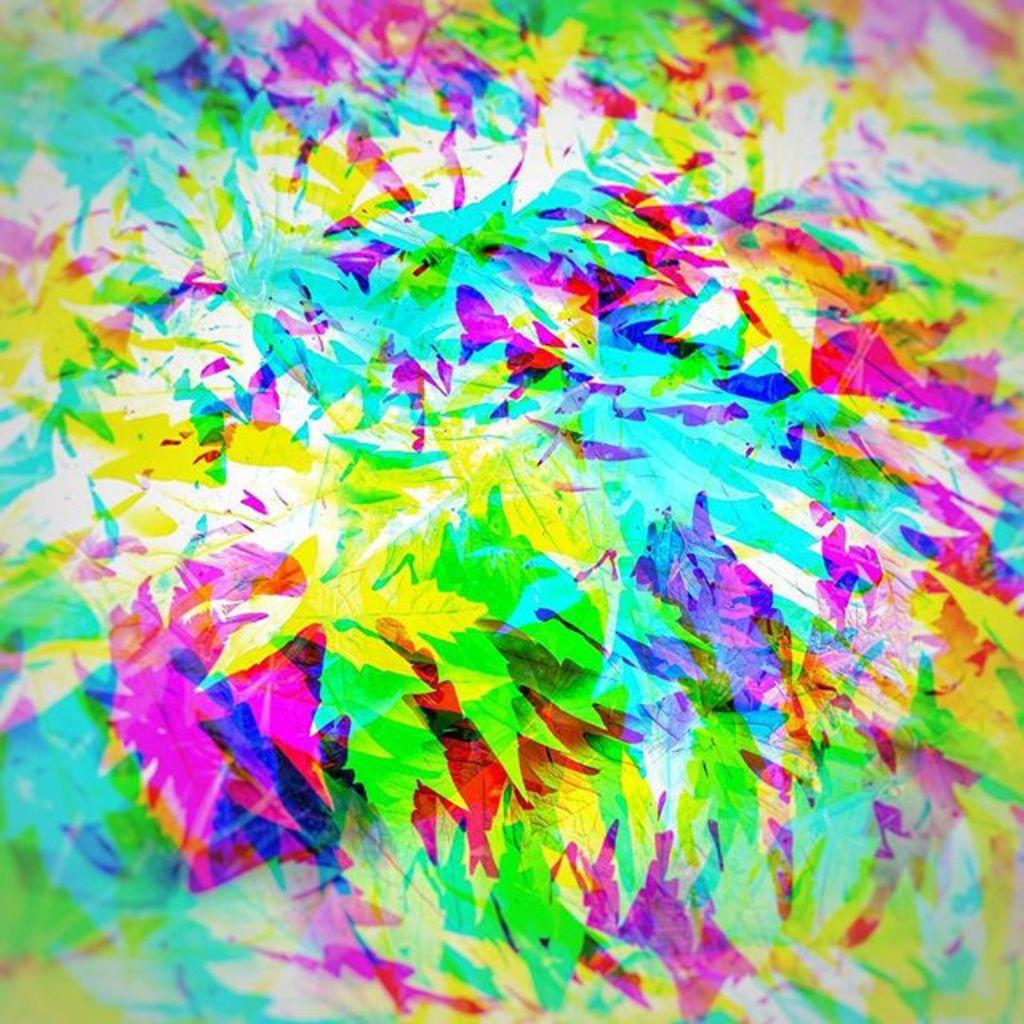What is the main subject of the image? The main subject of the image is an art piece. Can you describe the appearance of the art piece? The art piece has different colors and resembles leaves. Can you tell me how many turkeys are depicted in the art piece? There are no turkeys depicted in the art piece; it resembles leaves. What type of friction is created by the art piece in the image? The art piece is stationary in the image, so it does not create any friction. 